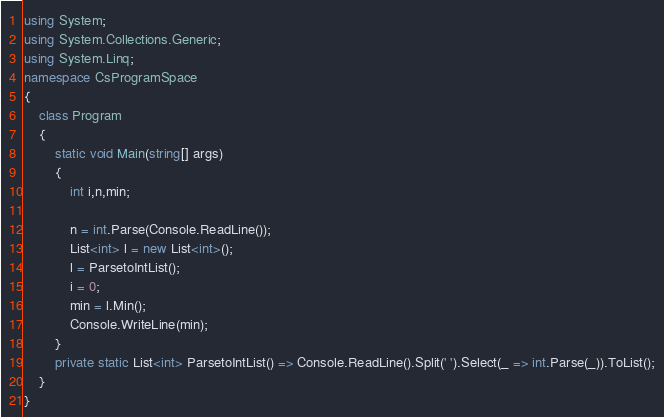Convert code to text. <code><loc_0><loc_0><loc_500><loc_500><_C#_>using System;
using System.Collections.Generic;
using System.Linq;
namespace CsProgramSpace
{
    class Program
    {
        static void Main(string[] args)
        {
            int i,n,min;
            
            n = int.Parse(Console.ReadLine());
            List<int> l = new List<int>();
            l = ParsetoIntList();
            i = 0;
            min = l.Min();
            Console.WriteLine(min);
        }
        private static List<int> ParsetoIntList() => Console.ReadLine().Split(' ').Select(_ => int.Parse(_)).ToList();
    }
}</code> 